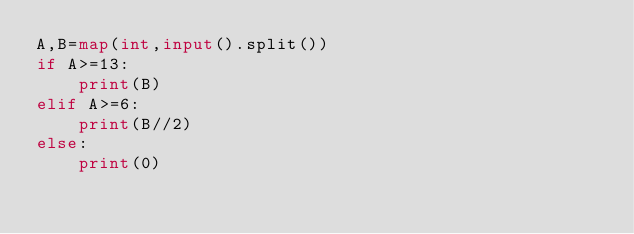Convert code to text. <code><loc_0><loc_0><loc_500><loc_500><_Python_>A,B=map(int,input().split())
if A>=13:
    print(B)
elif A>=6:
    print(B//2)
else:
    print(0)</code> 